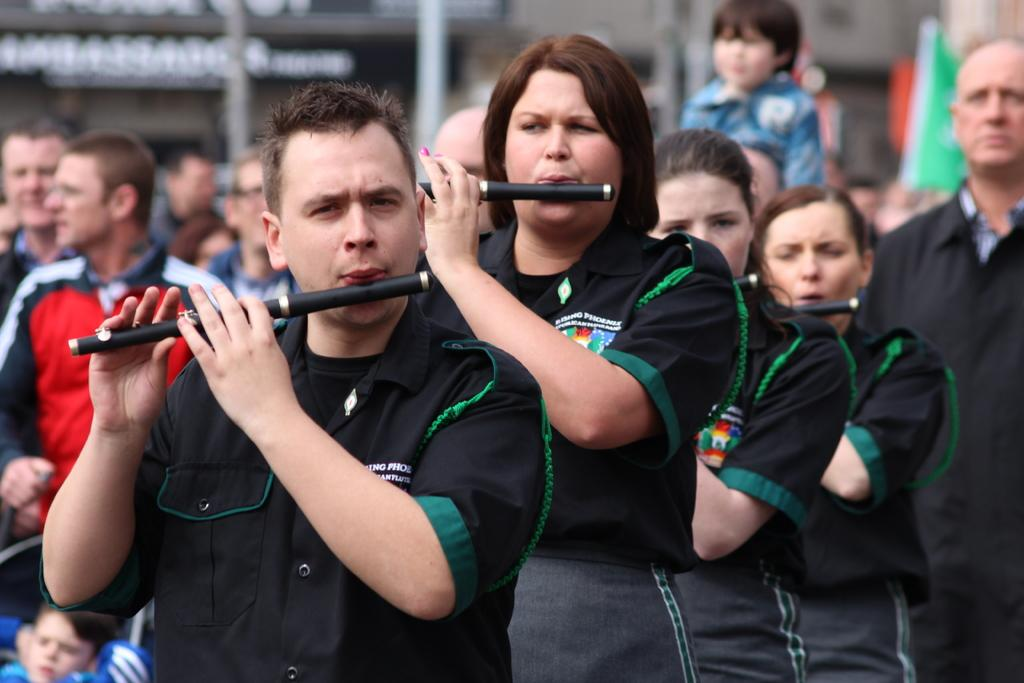What is happening in the image involving a group of people? There is a group of people in the image, and they are playing the flute. How are the people positioned in the image? The people are standing next to each other. Can you describe the man on the right side of the group? There is a man standing at the right side of the group. What can be seen in the background of the image? There is a building in the background of the image. What type of dolls are being used for reading in the image? There are no dolls or reading materials present in the image; it features a group of people playing the flute. What type of industry can be seen in the background of the image? There is no industry visible in the background of the image; it features a building. 